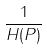<formula> <loc_0><loc_0><loc_500><loc_500>\frac { 1 } { H ( P ) }</formula> 